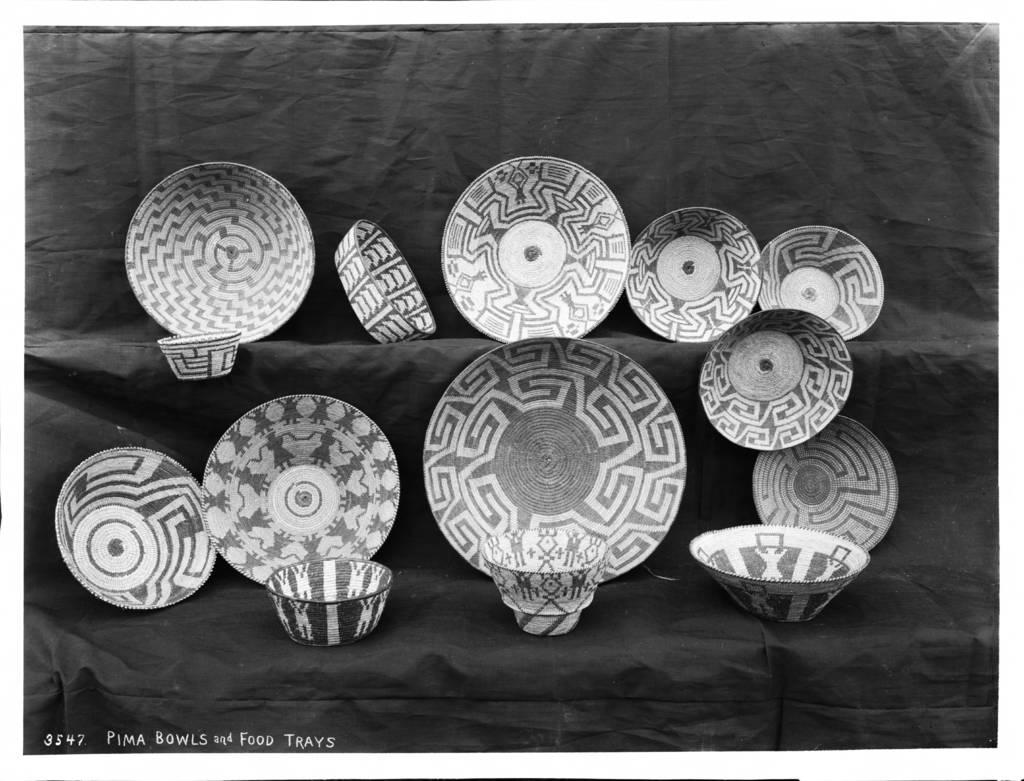What is the color scheme of the image? The image is black and white. What color is the background of the image? The background of the image is black. What type of objects can be seen in the image? There are plates and bowls in the image. Where are the plates and bowls located? The plates and bowls are on shelves. Can you see any smoke coming from the cellar in the image? There is no cellar or smoke present in the image. What type of army is depicted in the image? There is no army depicted in the image; it features plates and bowls on shelves. 